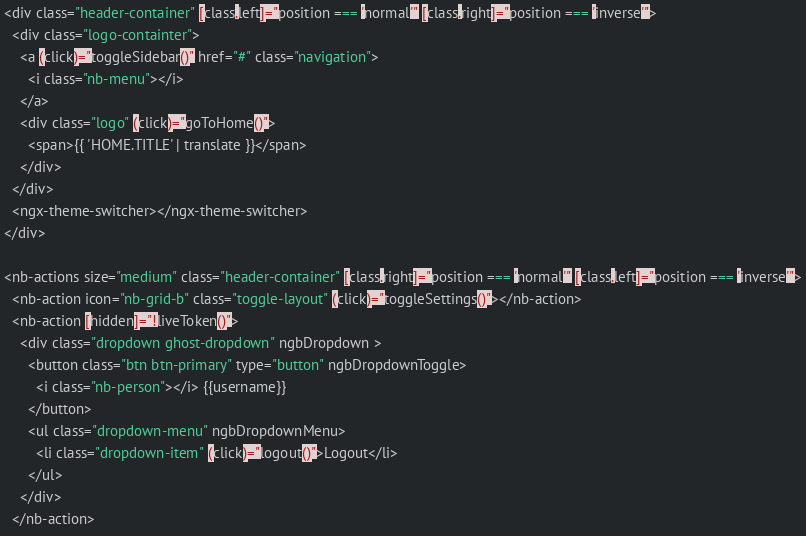Convert code to text. <code><loc_0><loc_0><loc_500><loc_500><_HTML_><div class="header-container" [class.left]="position === 'normal'" [class.right]="position === 'inverse'">
  <div class="logo-containter">
    <a (click)="toggleSidebar()" href="#" class="navigation">
      <i class="nb-menu"></i>
    </a>
    <div class="logo" (click)="goToHome()">
      <span>{{ 'HOME.TITLE' | translate }}</span>
    </div>
  </div>
  <ngx-theme-switcher></ngx-theme-switcher>
</div>

<nb-actions size="medium" class="header-container" [class.right]="position === 'normal'" [class.left]="position === 'inverse'">
  <nb-action icon="nb-grid-b" class="toggle-layout" (click)="toggleSettings()"></nb-action>
  <nb-action [hidden]="!liveToken()"> 
    <div class="dropdown ghost-dropdown" ngbDropdown >
      <button class="btn btn-primary" type="button" ngbDropdownToggle>
        <i class="nb-person"></i> {{username}}
      </button>
      <ul class="dropdown-menu" ngbDropdownMenu>
        <li class="dropdown-item" (click)="logout()">Logout</li>
      </ul>
    </div>
  </nb-action></code> 